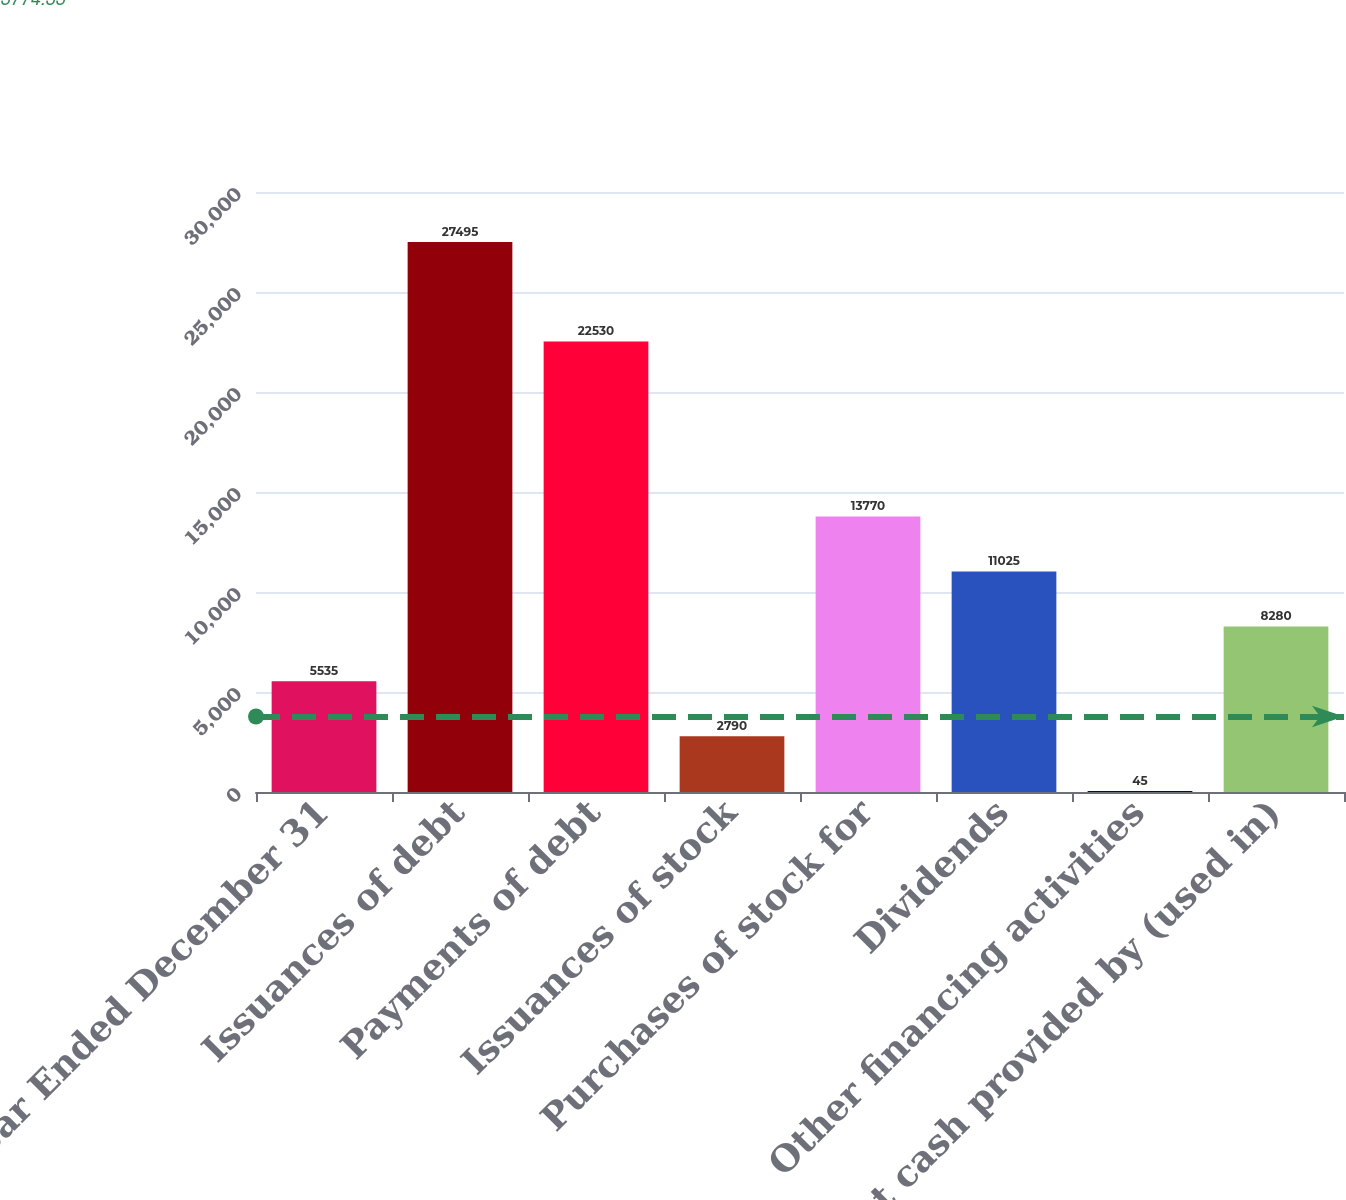<chart> <loc_0><loc_0><loc_500><loc_500><bar_chart><fcel>Year Ended December 31<fcel>Issuances of debt<fcel>Payments of debt<fcel>Issuances of stock<fcel>Purchases of stock for<fcel>Dividends<fcel>Other financing activities<fcel>Net cash provided by (used in)<nl><fcel>5535<fcel>27495<fcel>22530<fcel>2790<fcel>13770<fcel>11025<fcel>45<fcel>8280<nl></chart> 